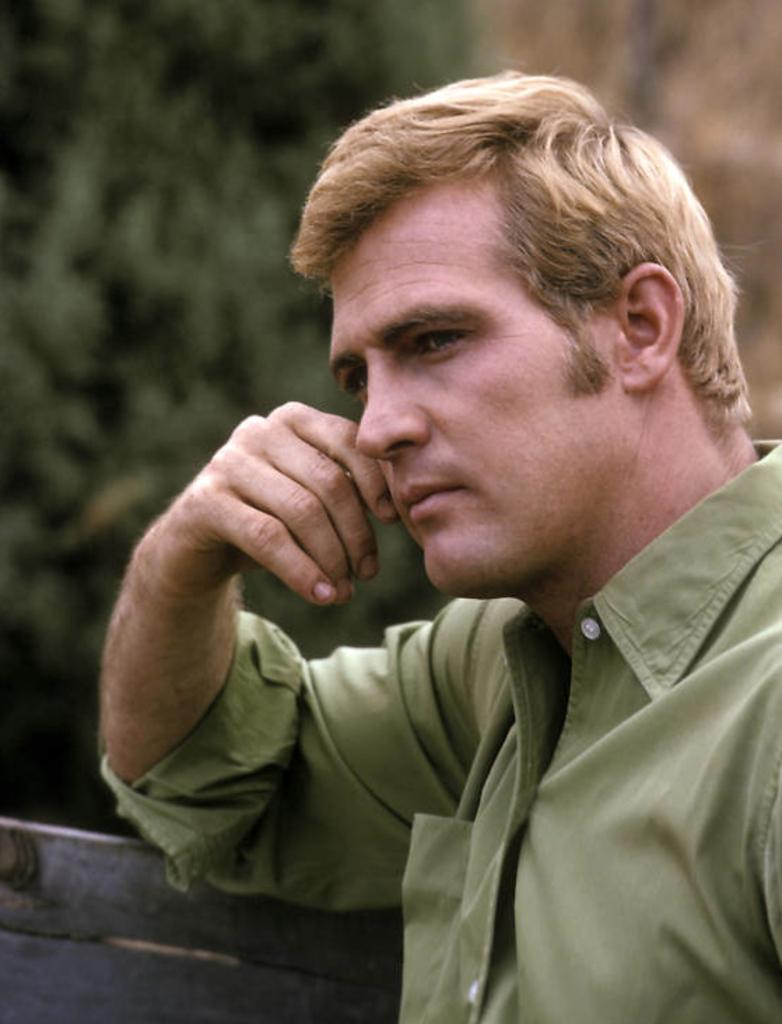Who is present in the image? There is a man in the image. What is the man wearing? The man is wearing a shirt. What type of object can be seen in the image? There is a wooden object in the image. What can be seen in the background of the image? There are blurred trees in the background of the image. What type of egg is being used as a fan in the image? There is no egg or fan present in the image. 